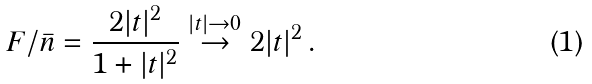Convert formula to latex. <formula><loc_0><loc_0><loc_500><loc_500>F / \bar { n } = \frac { 2 | t | ^ { 2 } } { 1 + | t | ^ { 2 } } \stackrel { | t | \rightarrow 0 } { \rightarrow } 2 | t | ^ { 2 } \, .</formula> 